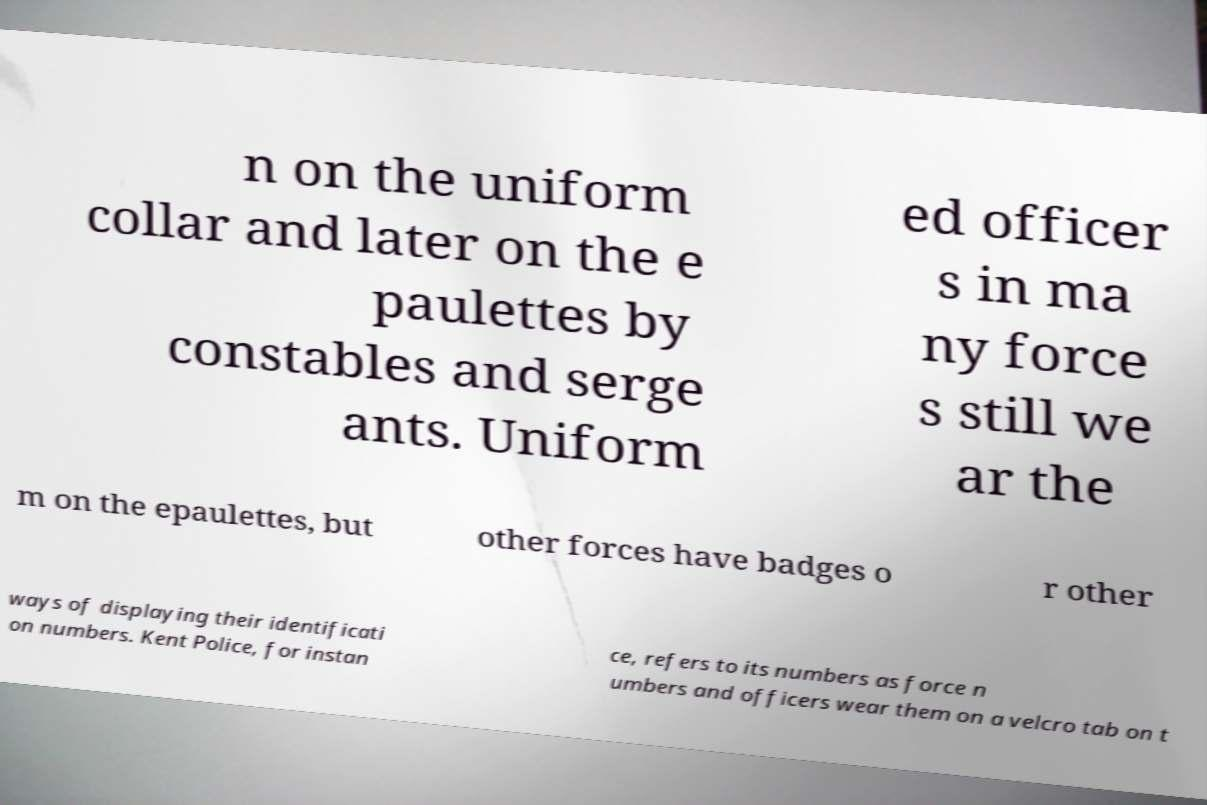Please identify and transcribe the text found in this image. n on the uniform collar and later on the e paulettes by constables and serge ants. Uniform ed officer s in ma ny force s still we ar the m on the epaulettes, but other forces have badges o r other ways of displaying their identificati on numbers. Kent Police, for instan ce, refers to its numbers as force n umbers and officers wear them on a velcro tab on t 